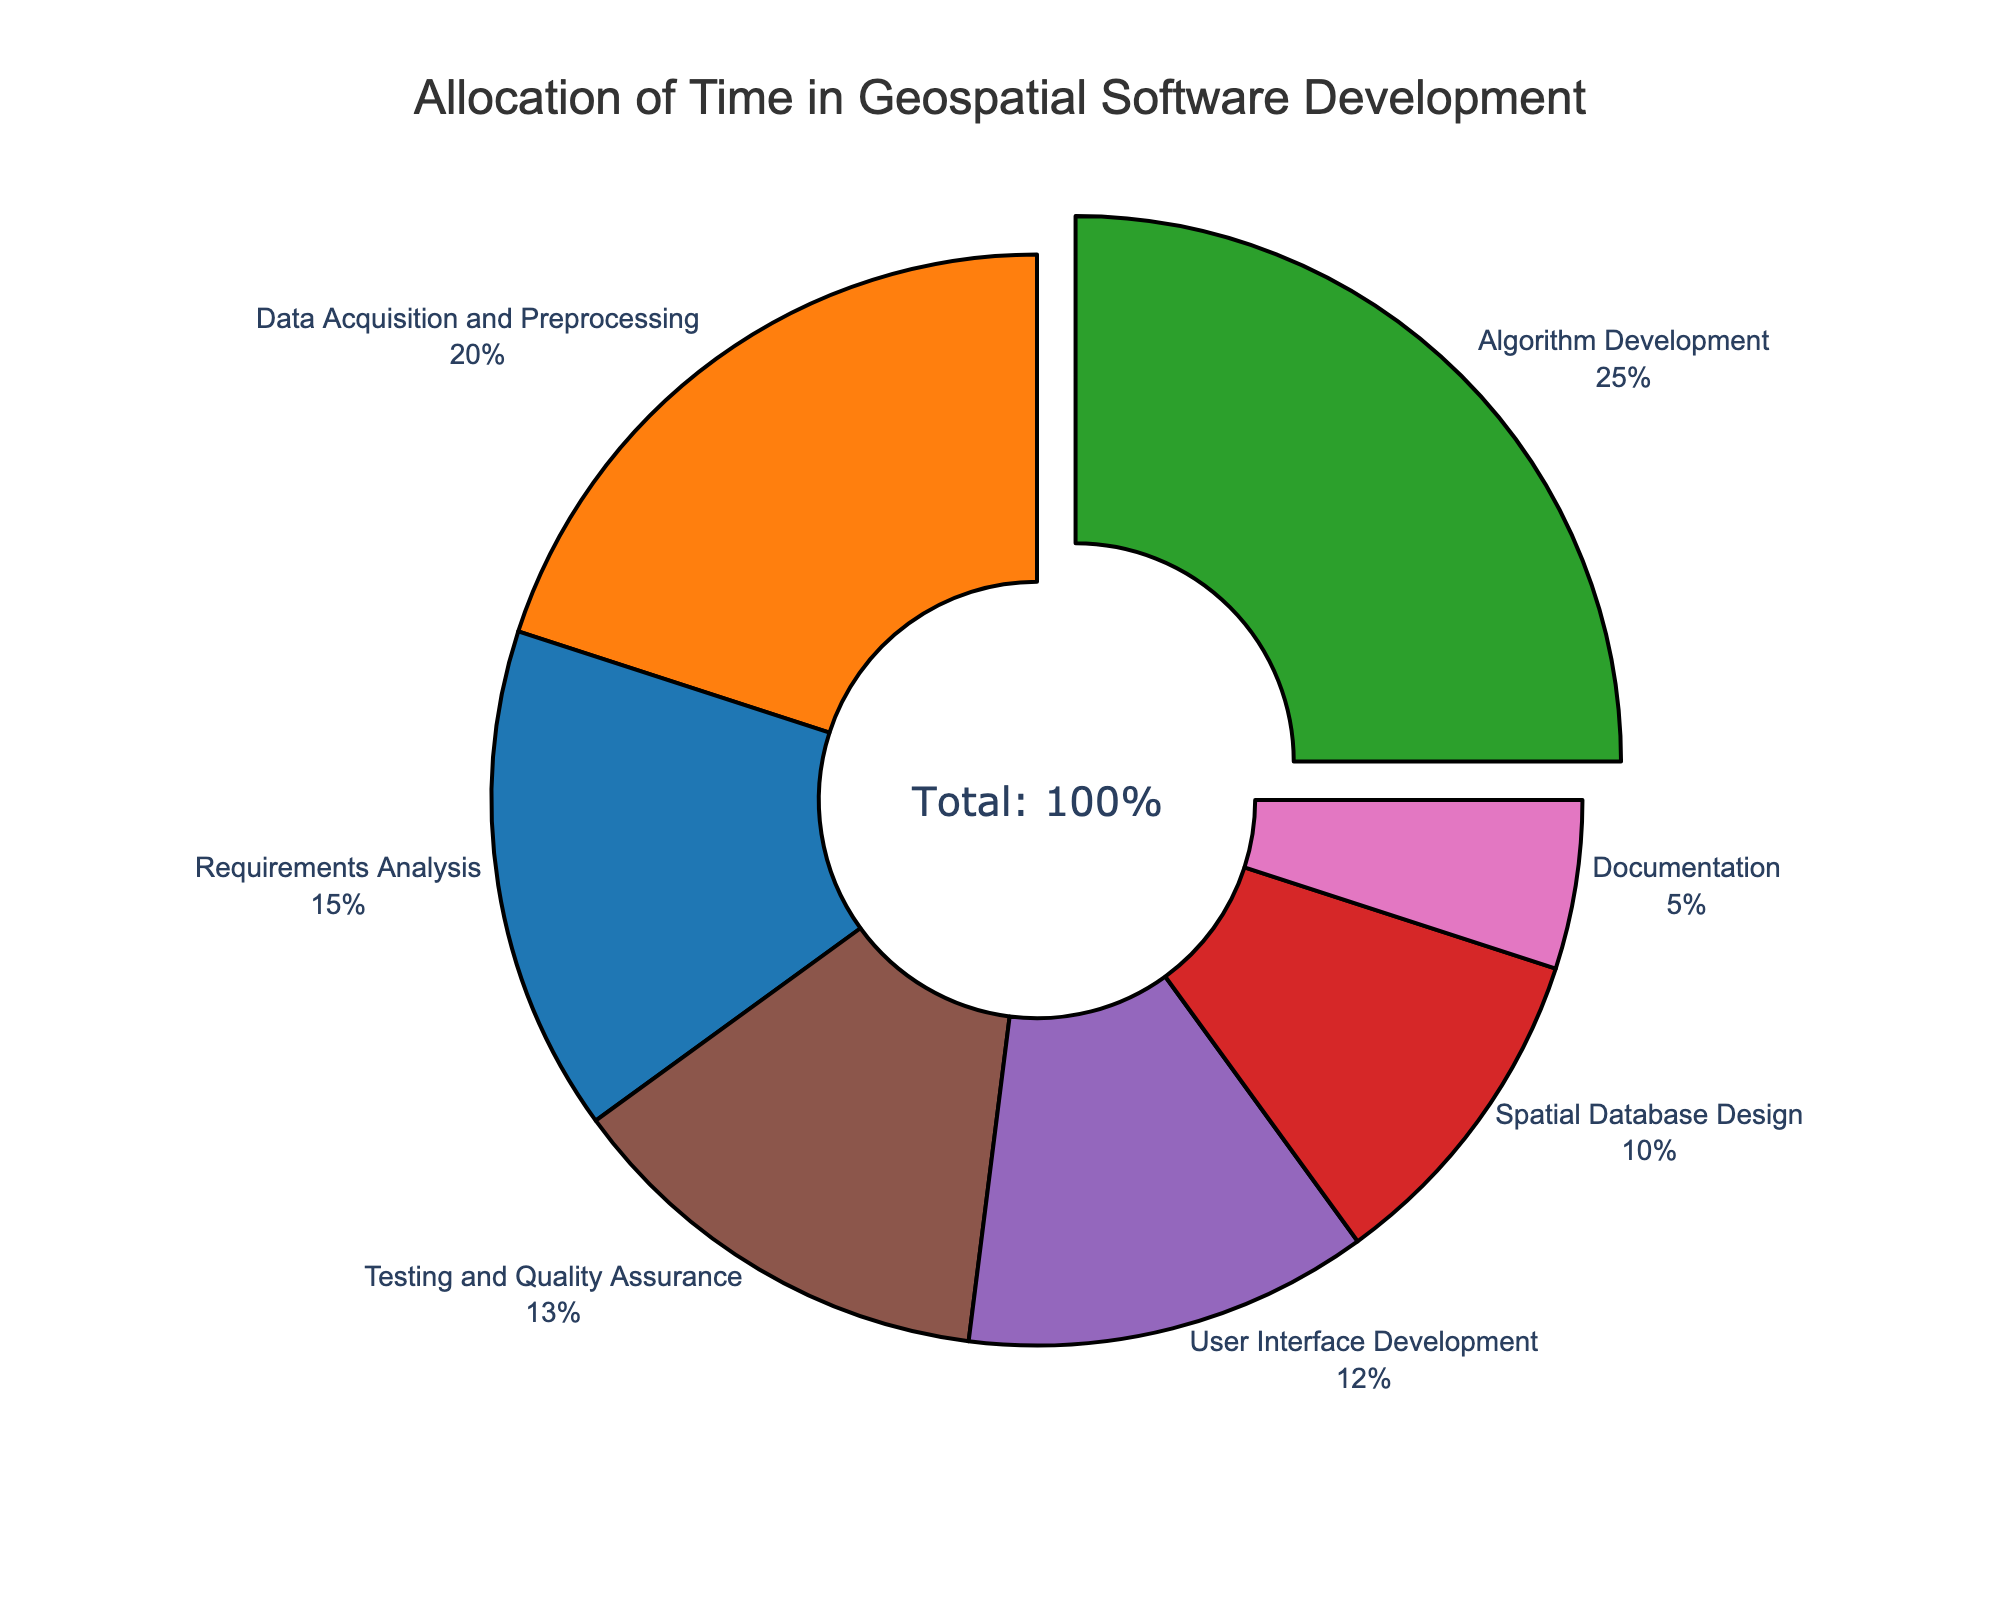What's the largest allocation of time in the development process? Find the phase with the highest percentage value. The largest allocation is for "Algorithm Development" at 25%.
Answer: Algorithm Development What's the sum of time allocated to Data Acquisition and Preprocessing and Testing and Quality Assurance? Add the percentage values of Data Acquisition and Preprocessing (20%) and Testing and Quality Assurance (13%): 20% + 13% = 33%.
Answer: 33% Which phase has a higher time allocation: User Interface Development or Documentation? Compare the percentage values of User Interface Development (12%) and Documentation (5%). User Interface Development is higher.
Answer: User Interface Development What's the difference in time allocation between Spatial Database Design and Requirements Analysis? Subtract the percentage of Spatial Database Design (10%) from Requirements Analysis (15%): 15% - 10% = 5%.
Answer: 5% Which phase's allocation is represented by the smallest slice in the pie chart? Identify the smallest percentage value. Documentation has the smallest allocation at 5%.
Answer: Documentation What’s the combined percentage of time spent on Requirements Analysis, Data Acquisition and Preprocessing, and Algorithm Development? Sum the percentages of each phase: 15% (Requirements Analysis) + 20% (Data Acquisition and Preprocessing) + 25% (Algorithm Development): 15% + 20% + 25% = 60%.
Answer: 60% Which phase has a larger percentage: Data Acquisition and Preprocessing or Testing and Quality Assurance? Compare the percentage values. Data Acquisition and Preprocessing (20%) is larger than Testing and Quality Assurance (13%).
Answer: Data Acquisition and Preprocessing What percentage of time is allocated to development phases involving user interaction (User Interface Development and Documentation)? Sum the percentages of User Interface Development (12%) and Documentation (5%): 12% + 5% = 17%.
Answer: 17% What’s the average percentage allocation across all phases? Sum all percentages and divide by the number of phases: (15% + 20% + 25% + 10% + 12% + 13% + 5%) / 7 = 100% / 7 ≈ 14.29%.
Answer: 14.29% 